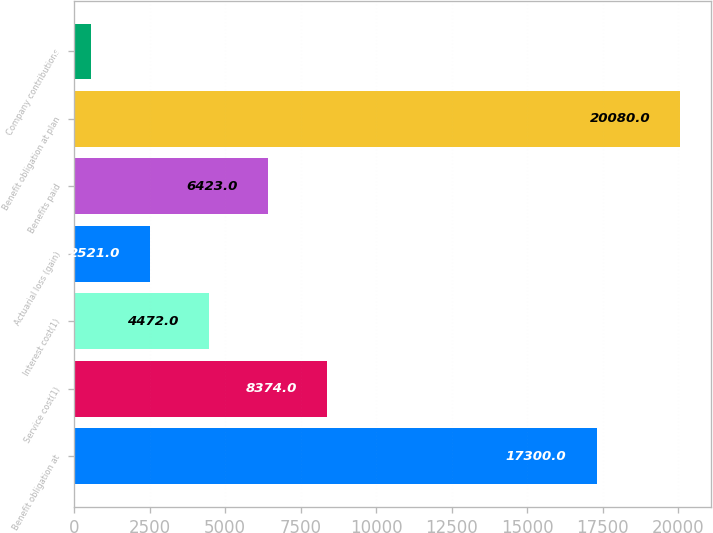Convert chart to OTSL. <chart><loc_0><loc_0><loc_500><loc_500><bar_chart><fcel>Benefit obligation at<fcel>Service cost(1)<fcel>Interest cost(1)<fcel>Actuarial loss (gain)<fcel>Benefits paid<fcel>Benefit obligation at plan<fcel>Company contributions<nl><fcel>17300<fcel>8374<fcel>4472<fcel>2521<fcel>6423<fcel>20080<fcel>570<nl></chart> 